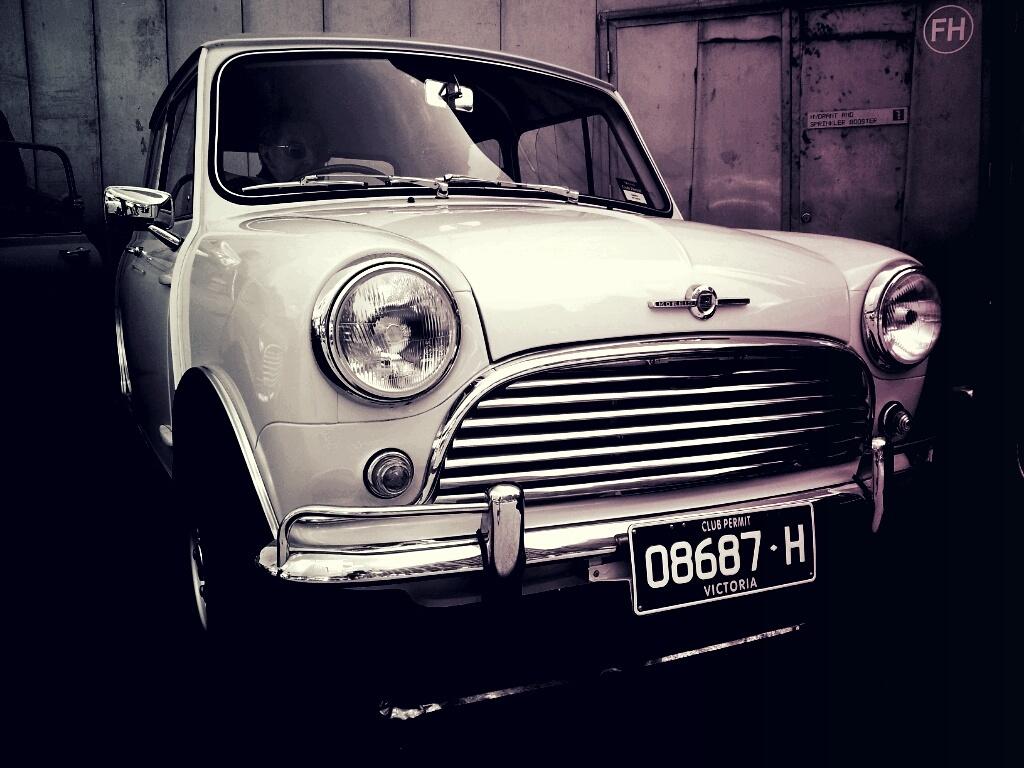Where was the license plate of this car issued?
Your response must be concise. Victoria. 